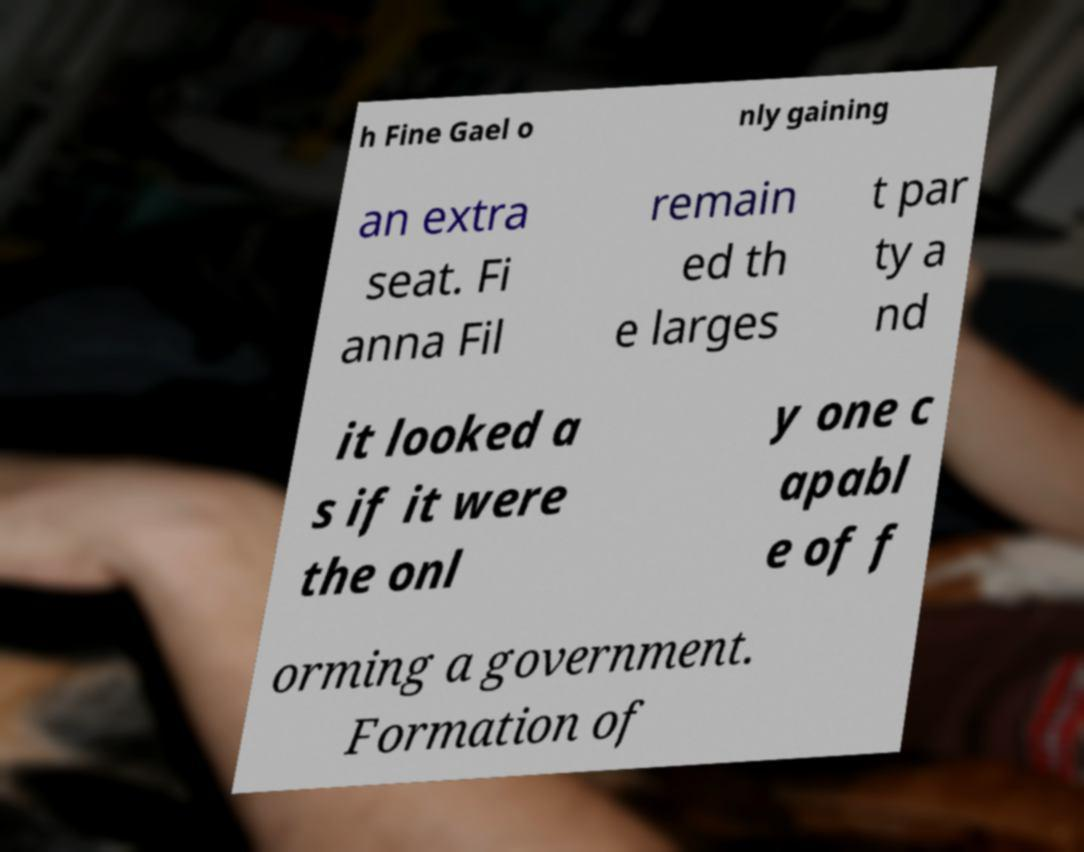Please read and relay the text visible in this image. What does it say? h Fine Gael o nly gaining an extra seat. Fi anna Fil remain ed th e larges t par ty a nd it looked a s if it were the onl y one c apabl e of f orming a government. Formation of 